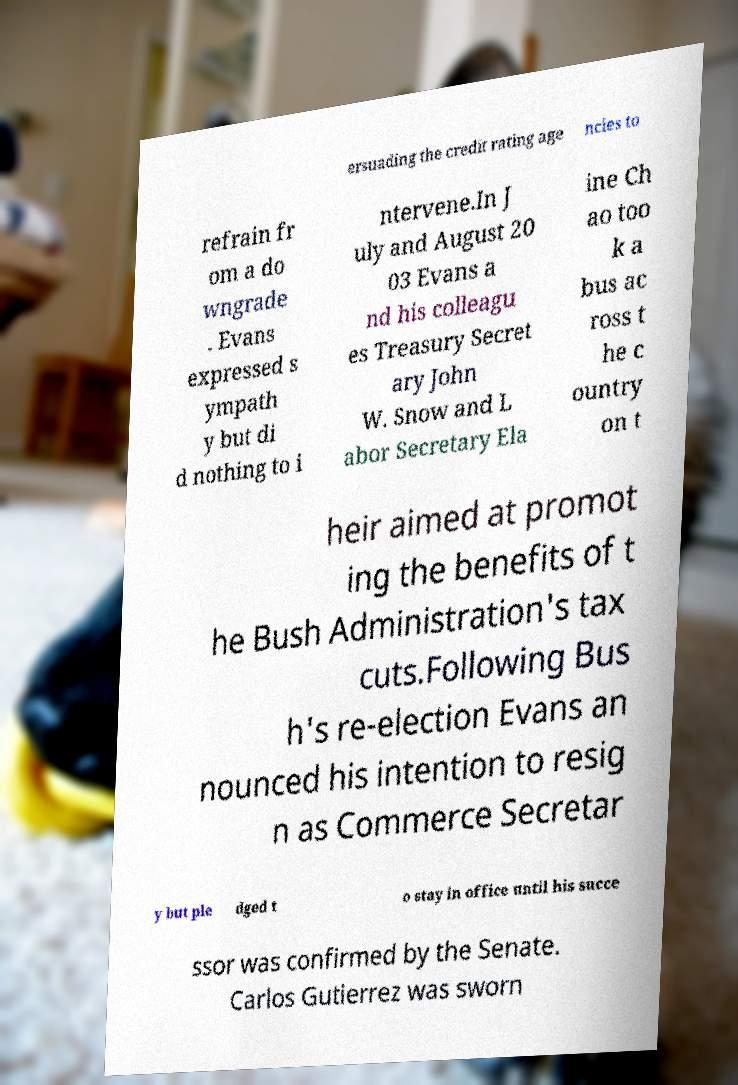Could you extract and type out the text from this image? ersuading the credit rating age ncies to refrain fr om a do wngrade . Evans expressed s ympath y but di d nothing to i ntervene.In J uly and August 20 03 Evans a nd his colleagu es Treasury Secret ary John W. Snow and L abor Secretary Ela ine Ch ao too k a bus ac ross t he c ountry on t heir aimed at promot ing the benefits of t he Bush Administration's tax cuts.Following Bus h's re-election Evans an nounced his intention to resig n as Commerce Secretar y but ple dged t o stay in office until his succe ssor was confirmed by the Senate. Carlos Gutierrez was sworn 